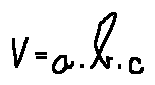Convert formula to latex. <formula><loc_0><loc_0><loc_500><loc_500>V = a \cdot b \cdot c</formula> 